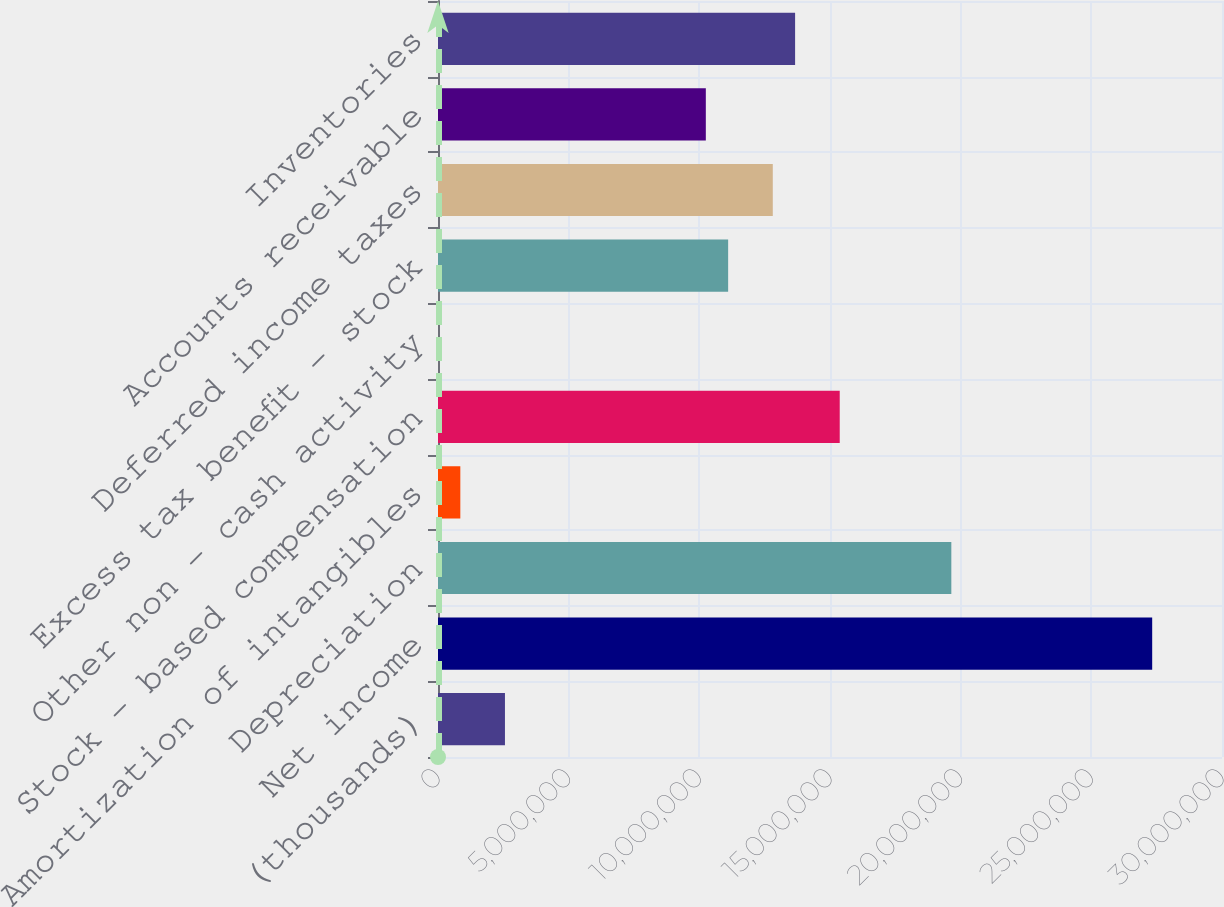Convert chart to OTSL. <chart><loc_0><loc_0><loc_500><loc_500><bar_chart><fcel>(thousands)<fcel>Net income<fcel>Depreciation<fcel>Amortization of intangibles<fcel>Stock - based compensation<fcel>Other non - cash activity<fcel>Excess tax benefit - stock<fcel>Deferred income taxes<fcel>Accounts receivable<fcel>Inventories<nl><fcel>2.56223e+06<fcel>2.73287e+07<fcel>1.96425e+07<fcel>854200<fcel>1.53725e+07<fcel>185<fcel>1.11024e+07<fcel>1.28104e+07<fcel>1.02484e+07<fcel>1.36644e+07<nl></chart> 